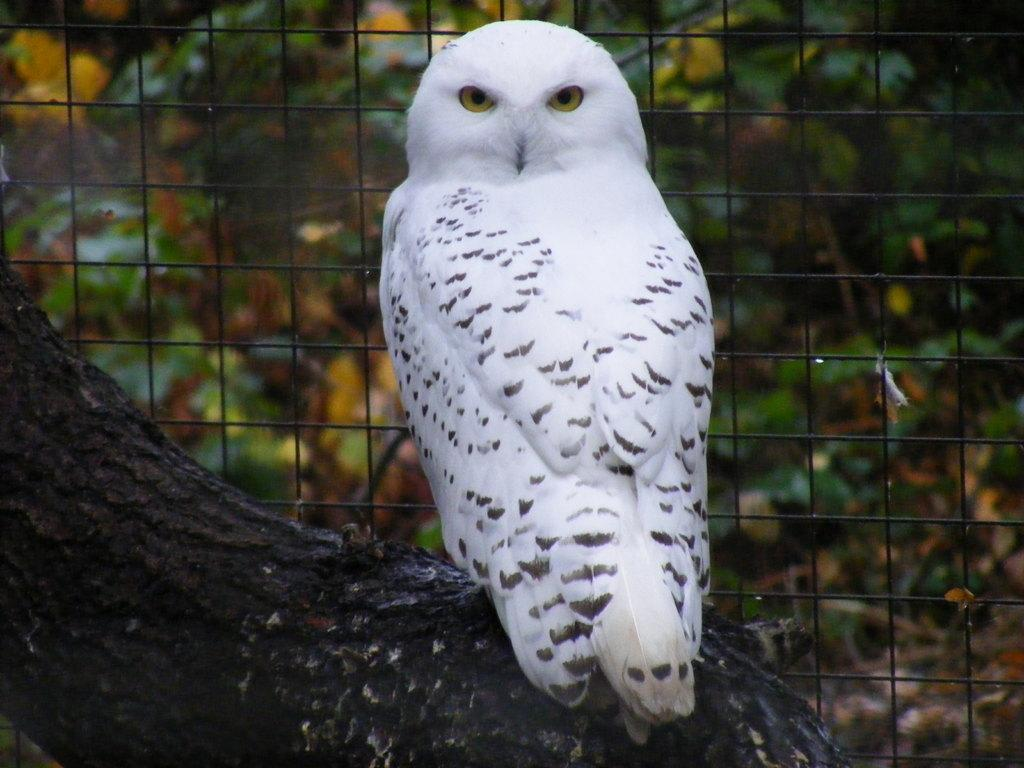What is the main object in the foreground of the image? There is a tree trunk in the image. What type of animal can be seen in the image? There is a white owl in the image. What structure is visible in the image? There is a fence in the image. What can be seen in the background of the image? There are trees in the background of the image. What type of footwear is the owl wearing in the image? The image does not show the owl wearing any footwear, as owls do not wear shoes. 